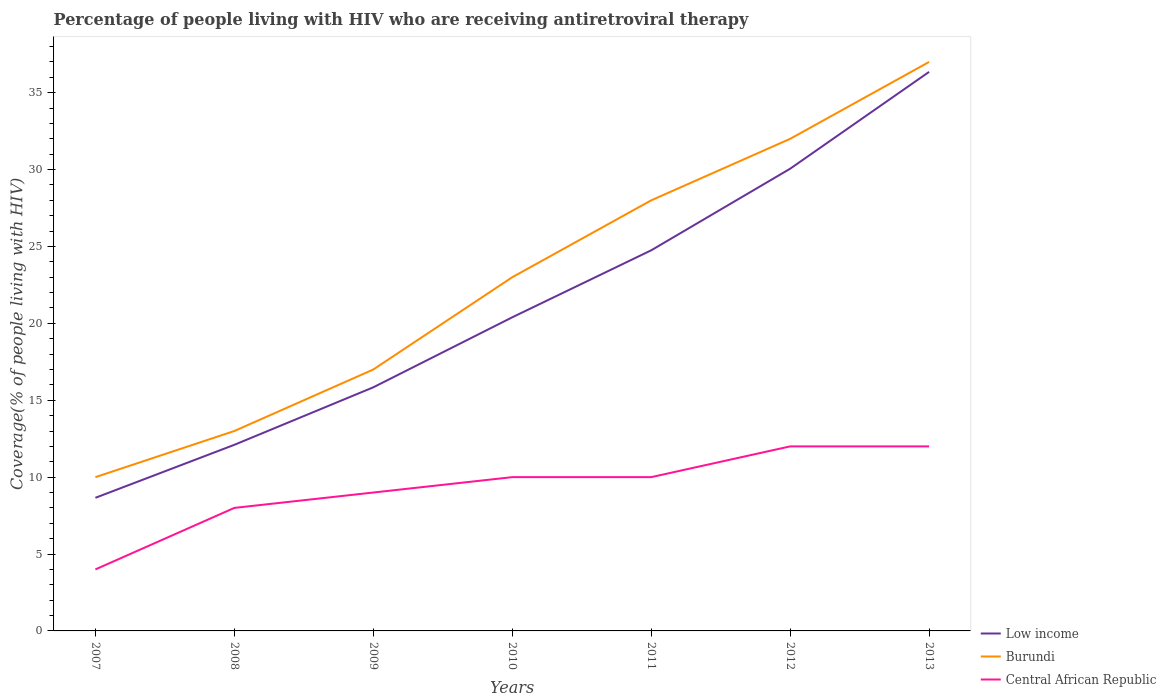How many different coloured lines are there?
Your answer should be very brief. 3. Does the line corresponding to Burundi intersect with the line corresponding to Low income?
Offer a very short reply. No. Is the number of lines equal to the number of legend labels?
Your answer should be compact. Yes. Across all years, what is the maximum percentage of the HIV infected people who are receiving antiretroviral therapy in Low income?
Make the answer very short. 8.66. In which year was the percentage of the HIV infected people who are receiving antiretroviral therapy in Burundi maximum?
Make the answer very short. 2007. What is the total percentage of the HIV infected people who are receiving antiretroviral therapy in Burundi in the graph?
Your response must be concise. -15. What is the difference between the highest and the second highest percentage of the HIV infected people who are receiving antiretroviral therapy in Low income?
Your answer should be compact. 27.7. Is the percentage of the HIV infected people who are receiving antiretroviral therapy in Central African Republic strictly greater than the percentage of the HIV infected people who are receiving antiretroviral therapy in Burundi over the years?
Offer a terse response. Yes. How many lines are there?
Make the answer very short. 3. What is the title of the graph?
Provide a short and direct response. Percentage of people living with HIV who are receiving antiretroviral therapy. Does "Sub-Saharan Africa (developing only)" appear as one of the legend labels in the graph?
Your answer should be very brief. No. What is the label or title of the X-axis?
Make the answer very short. Years. What is the label or title of the Y-axis?
Your response must be concise. Coverage(% of people living with HIV). What is the Coverage(% of people living with HIV) of Low income in 2007?
Provide a short and direct response. 8.66. What is the Coverage(% of people living with HIV) of Central African Republic in 2007?
Offer a terse response. 4. What is the Coverage(% of people living with HIV) of Low income in 2008?
Give a very brief answer. 12.1. What is the Coverage(% of people living with HIV) of Low income in 2009?
Provide a short and direct response. 15.84. What is the Coverage(% of people living with HIV) of Burundi in 2009?
Give a very brief answer. 17. What is the Coverage(% of people living with HIV) of Central African Republic in 2009?
Your answer should be very brief. 9. What is the Coverage(% of people living with HIV) in Low income in 2010?
Offer a terse response. 20.39. What is the Coverage(% of people living with HIV) of Central African Republic in 2010?
Your answer should be compact. 10. What is the Coverage(% of people living with HIV) in Low income in 2011?
Keep it short and to the point. 24.75. What is the Coverage(% of people living with HIV) in Burundi in 2011?
Ensure brevity in your answer.  28. What is the Coverage(% of people living with HIV) of Central African Republic in 2011?
Keep it short and to the point. 10. What is the Coverage(% of people living with HIV) of Low income in 2012?
Provide a short and direct response. 30.06. What is the Coverage(% of people living with HIV) of Burundi in 2012?
Your answer should be compact. 32. What is the Coverage(% of people living with HIV) in Central African Republic in 2012?
Make the answer very short. 12. What is the Coverage(% of people living with HIV) of Low income in 2013?
Your answer should be very brief. 36.35. Across all years, what is the maximum Coverage(% of people living with HIV) of Low income?
Ensure brevity in your answer.  36.35. Across all years, what is the maximum Coverage(% of people living with HIV) in Burundi?
Keep it short and to the point. 37. Across all years, what is the maximum Coverage(% of people living with HIV) in Central African Republic?
Offer a terse response. 12. Across all years, what is the minimum Coverage(% of people living with HIV) of Low income?
Offer a terse response. 8.66. Across all years, what is the minimum Coverage(% of people living with HIV) of Burundi?
Provide a short and direct response. 10. Across all years, what is the minimum Coverage(% of people living with HIV) of Central African Republic?
Provide a short and direct response. 4. What is the total Coverage(% of people living with HIV) in Low income in the graph?
Offer a very short reply. 148.16. What is the total Coverage(% of people living with HIV) of Burundi in the graph?
Your answer should be very brief. 160. What is the difference between the Coverage(% of people living with HIV) in Low income in 2007 and that in 2008?
Your answer should be compact. -3.45. What is the difference between the Coverage(% of people living with HIV) in Burundi in 2007 and that in 2008?
Make the answer very short. -3. What is the difference between the Coverage(% of people living with HIV) in Central African Republic in 2007 and that in 2008?
Your response must be concise. -4. What is the difference between the Coverage(% of people living with HIV) of Low income in 2007 and that in 2009?
Your response must be concise. -7.18. What is the difference between the Coverage(% of people living with HIV) of Burundi in 2007 and that in 2009?
Give a very brief answer. -7. What is the difference between the Coverage(% of people living with HIV) in Central African Republic in 2007 and that in 2009?
Provide a short and direct response. -5. What is the difference between the Coverage(% of people living with HIV) in Low income in 2007 and that in 2010?
Your answer should be compact. -11.74. What is the difference between the Coverage(% of people living with HIV) of Low income in 2007 and that in 2011?
Ensure brevity in your answer.  -16.09. What is the difference between the Coverage(% of people living with HIV) in Burundi in 2007 and that in 2011?
Keep it short and to the point. -18. What is the difference between the Coverage(% of people living with HIV) in Low income in 2007 and that in 2012?
Keep it short and to the point. -21.4. What is the difference between the Coverage(% of people living with HIV) of Burundi in 2007 and that in 2012?
Ensure brevity in your answer.  -22. What is the difference between the Coverage(% of people living with HIV) in Low income in 2007 and that in 2013?
Provide a short and direct response. -27.7. What is the difference between the Coverage(% of people living with HIV) of Burundi in 2007 and that in 2013?
Keep it short and to the point. -27. What is the difference between the Coverage(% of people living with HIV) of Central African Republic in 2007 and that in 2013?
Give a very brief answer. -8. What is the difference between the Coverage(% of people living with HIV) of Low income in 2008 and that in 2009?
Offer a terse response. -3.74. What is the difference between the Coverage(% of people living with HIV) in Burundi in 2008 and that in 2009?
Offer a very short reply. -4. What is the difference between the Coverage(% of people living with HIV) in Central African Republic in 2008 and that in 2009?
Provide a succinct answer. -1. What is the difference between the Coverage(% of people living with HIV) in Low income in 2008 and that in 2010?
Offer a very short reply. -8.29. What is the difference between the Coverage(% of people living with HIV) in Burundi in 2008 and that in 2010?
Give a very brief answer. -10. What is the difference between the Coverage(% of people living with HIV) in Central African Republic in 2008 and that in 2010?
Ensure brevity in your answer.  -2. What is the difference between the Coverage(% of people living with HIV) in Low income in 2008 and that in 2011?
Your answer should be compact. -12.65. What is the difference between the Coverage(% of people living with HIV) of Burundi in 2008 and that in 2011?
Give a very brief answer. -15. What is the difference between the Coverage(% of people living with HIV) in Low income in 2008 and that in 2012?
Offer a terse response. -17.95. What is the difference between the Coverage(% of people living with HIV) in Central African Republic in 2008 and that in 2012?
Provide a succinct answer. -4. What is the difference between the Coverage(% of people living with HIV) of Low income in 2008 and that in 2013?
Ensure brevity in your answer.  -24.25. What is the difference between the Coverage(% of people living with HIV) in Burundi in 2008 and that in 2013?
Ensure brevity in your answer.  -24. What is the difference between the Coverage(% of people living with HIV) of Low income in 2009 and that in 2010?
Provide a short and direct response. -4.55. What is the difference between the Coverage(% of people living with HIV) of Burundi in 2009 and that in 2010?
Provide a succinct answer. -6. What is the difference between the Coverage(% of people living with HIV) of Central African Republic in 2009 and that in 2010?
Your answer should be very brief. -1. What is the difference between the Coverage(% of people living with HIV) of Low income in 2009 and that in 2011?
Give a very brief answer. -8.91. What is the difference between the Coverage(% of people living with HIV) in Burundi in 2009 and that in 2011?
Give a very brief answer. -11. What is the difference between the Coverage(% of people living with HIV) in Low income in 2009 and that in 2012?
Give a very brief answer. -14.21. What is the difference between the Coverage(% of people living with HIV) of Burundi in 2009 and that in 2012?
Offer a terse response. -15. What is the difference between the Coverage(% of people living with HIV) in Low income in 2009 and that in 2013?
Provide a succinct answer. -20.51. What is the difference between the Coverage(% of people living with HIV) of Burundi in 2009 and that in 2013?
Your answer should be compact. -20. What is the difference between the Coverage(% of people living with HIV) in Central African Republic in 2009 and that in 2013?
Keep it short and to the point. -3. What is the difference between the Coverage(% of people living with HIV) of Low income in 2010 and that in 2011?
Ensure brevity in your answer.  -4.36. What is the difference between the Coverage(% of people living with HIV) of Burundi in 2010 and that in 2011?
Give a very brief answer. -5. What is the difference between the Coverage(% of people living with HIV) of Central African Republic in 2010 and that in 2011?
Make the answer very short. 0. What is the difference between the Coverage(% of people living with HIV) in Low income in 2010 and that in 2012?
Provide a short and direct response. -9.66. What is the difference between the Coverage(% of people living with HIV) in Central African Republic in 2010 and that in 2012?
Make the answer very short. -2. What is the difference between the Coverage(% of people living with HIV) in Low income in 2010 and that in 2013?
Make the answer very short. -15.96. What is the difference between the Coverage(% of people living with HIV) of Low income in 2011 and that in 2012?
Your response must be concise. -5.31. What is the difference between the Coverage(% of people living with HIV) of Central African Republic in 2011 and that in 2012?
Provide a short and direct response. -2. What is the difference between the Coverage(% of people living with HIV) in Low income in 2011 and that in 2013?
Keep it short and to the point. -11.6. What is the difference between the Coverage(% of people living with HIV) in Central African Republic in 2011 and that in 2013?
Make the answer very short. -2. What is the difference between the Coverage(% of people living with HIV) in Low income in 2012 and that in 2013?
Provide a succinct answer. -6.3. What is the difference between the Coverage(% of people living with HIV) of Low income in 2007 and the Coverage(% of people living with HIV) of Burundi in 2008?
Provide a short and direct response. -4.34. What is the difference between the Coverage(% of people living with HIV) in Low income in 2007 and the Coverage(% of people living with HIV) in Central African Republic in 2008?
Provide a short and direct response. 0.66. What is the difference between the Coverage(% of people living with HIV) in Burundi in 2007 and the Coverage(% of people living with HIV) in Central African Republic in 2008?
Your response must be concise. 2. What is the difference between the Coverage(% of people living with HIV) in Low income in 2007 and the Coverage(% of people living with HIV) in Burundi in 2009?
Keep it short and to the point. -8.34. What is the difference between the Coverage(% of people living with HIV) in Low income in 2007 and the Coverage(% of people living with HIV) in Central African Republic in 2009?
Make the answer very short. -0.34. What is the difference between the Coverage(% of people living with HIV) of Low income in 2007 and the Coverage(% of people living with HIV) of Burundi in 2010?
Offer a very short reply. -14.34. What is the difference between the Coverage(% of people living with HIV) in Low income in 2007 and the Coverage(% of people living with HIV) in Central African Republic in 2010?
Offer a terse response. -1.34. What is the difference between the Coverage(% of people living with HIV) of Low income in 2007 and the Coverage(% of people living with HIV) of Burundi in 2011?
Your answer should be very brief. -19.34. What is the difference between the Coverage(% of people living with HIV) in Low income in 2007 and the Coverage(% of people living with HIV) in Central African Republic in 2011?
Offer a very short reply. -1.34. What is the difference between the Coverage(% of people living with HIV) of Burundi in 2007 and the Coverage(% of people living with HIV) of Central African Republic in 2011?
Your response must be concise. 0. What is the difference between the Coverage(% of people living with HIV) of Low income in 2007 and the Coverage(% of people living with HIV) of Burundi in 2012?
Your answer should be compact. -23.34. What is the difference between the Coverage(% of people living with HIV) of Low income in 2007 and the Coverage(% of people living with HIV) of Central African Republic in 2012?
Offer a terse response. -3.34. What is the difference between the Coverage(% of people living with HIV) of Burundi in 2007 and the Coverage(% of people living with HIV) of Central African Republic in 2012?
Ensure brevity in your answer.  -2. What is the difference between the Coverage(% of people living with HIV) in Low income in 2007 and the Coverage(% of people living with HIV) in Burundi in 2013?
Provide a succinct answer. -28.34. What is the difference between the Coverage(% of people living with HIV) in Low income in 2007 and the Coverage(% of people living with HIV) in Central African Republic in 2013?
Keep it short and to the point. -3.34. What is the difference between the Coverage(% of people living with HIV) of Low income in 2008 and the Coverage(% of people living with HIV) of Burundi in 2009?
Offer a very short reply. -4.9. What is the difference between the Coverage(% of people living with HIV) of Low income in 2008 and the Coverage(% of people living with HIV) of Central African Republic in 2009?
Ensure brevity in your answer.  3.1. What is the difference between the Coverage(% of people living with HIV) of Low income in 2008 and the Coverage(% of people living with HIV) of Burundi in 2010?
Give a very brief answer. -10.9. What is the difference between the Coverage(% of people living with HIV) in Low income in 2008 and the Coverage(% of people living with HIV) in Central African Republic in 2010?
Offer a very short reply. 2.1. What is the difference between the Coverage(% of people living with HIV) in Low income in 2008 and the Coverage(% of people living with HIV) in Burundi in 2011?
Keep it short and to the point. -15.9. What is the difference between the Coverage(% of people living with HIV) in Low income in 2008 and the Coverage(% of people living with HIV) in Central African Republic in 2011?
Make the answer very short. 2.1. What is the difference between the Coverage(% of people living with HIV) of Low income in 2008 and the Coverage(% of people living with HIV) of Burundi in 2012?
Your response must be concise. -19.9. What is the difference between the Coverage(% of people living with HIV) in Low income in 2008 and the Coverage(% of people living with HIV) in Central African Republic in 2012?
Your answer should be very brief. 0.1. What is the difference between the Coverage(% of people living with HIV) in Low income in 2008 and the Coverage(% of people living with HIV) in Burundi in 2013?
Your answer should be compact. -24.9. What is the difference between the Coverage(% of people living with HIV) of Low income in 2008 and the Coverage(% of people living with HIV) of Central African Republic in 2013?
Your response must be concise. 0.1. What is the difference between the Coverage(% of people living with HIV) in Burundi in 2008 and the Coverage(% of people living with HIV) in Central African Republic in 2013?
Your response must be concise. 1. What is the difference between the Coverage(% of people living with HIV) of Low income in 2009 and the Coverage(% of people living with HIV) of Burundi in 2010?
Offer a very short reply. -7.16. What is the difference between the Coverage(% of people living with HIV) of Low income in 2009 and the Coverage(% of people living with HIV) of Central African Republic in 2010?
Your response must be concise. 5.84. What is the difference between the Coverage(% of people living with HIV) in Low income in 2009 and the Coverage(% of people living with HIV) in Burundi in 2011?
Ensure brevity in your answer.  -12.16. What is the difference between the Coverage(% of people living with HIV) in Low income in 2009 and the Coverage(% of people living with HIV) in Central African Republic in 2011?
Give a very brief answer. 5.84. What is the difference between the Coverage(% of people living with HIV) of Burundi in 2009 and the Coverage(% of people living with HIV) of Central African Republic in 2011?
Offer a very short reply. 7. What is the difference between the Coverage(% of people living with HIV) of Low income in 2009 and the Coverage(% of people living with HIV) of Burundi in 2012?
Make the answer very short. -16.16. What is the difference between the Coverage(% of people living with HIV) in Low income in 2009 and the Coverage(% of people living with HIV) in Central African Republic in 2012?
Offer a very short reply. 3.84. What is the difference between the Coverage(% of people living with HIV) of Low income in 2009 and the Coverage(% of people living with HIV) of Burundi in 2013?
Give a very brief answer. -21.16. What is the difference between the Coverage(% of people living with HIV) of Low income in 2009 and the Coverage(% of people living with HIV) of Central African Republic in 2013?
Your response must be concise. 3.84. What is the difference between the Coverage(% of people living with HIV) in Burundi in 2009 and the Coverage(% of people living with HIV) in Central African Republic in 2013?
Your response must be concise. 5. What is the difference between the Coverage(% of people living with HIV) of Low income in 2010 and the Coverage(% of people living with HIV) of Burundi in 2011?
Your answer should be compact. -7.61. What is the difference between the Coverage(% of people living with HIV) in Low income in 2010 and the Coverage(% of people living with HIV) in Central African Republic in 2011?
Provide a succinct answer. 10.39. What is the difference between the Coverage(% of people living with HIV) of Burundi in 2010 and the Coverage(% of people living with HIV) of Central African Republic in 2011?
Make the answer very short. 13. What is the difference between the Coverage(% of people living with HIV) in Low income in 2010 and the Coverage(% of people living with HIV) in Burundi in 2012?
Your answer should be compact. -11.61. What is the difference between the Coverage(% of people living with HIV) in Low income in 2010 and the Coverage(% of people living with HIV) in Central African Republic in 2012?
Your response must be concise. 8.39. What is the difference between the Coverage(% of people living with HIV) in Burundi in 2010 and the Coverage(% of people living with HIV) in Central African Republic in 2012?
Provide a short and direct response. 11. What is the difference between the Coverage(% of people living with HIV) in Low income in 2010 and the Coverage(% of people living with HIV) in Burundi in 2013?
Give a very brief answer. -16.61. What is the difference between the Coverage(% of people living with HIV) of Low income in 2010 and the Coverage(% of people living with HIV) of Central African Republic in 2013?
Your answer should be very brief. 8.39. What is the difference between the Coverage(% of people living with HIV) in Burundi in 2010 and the Coverage(% of people living with HIV) in Central African Republic in 2013?
Offer a very short reply. 11. What is the difference between the Coverage(% of people living with HIV) in Low income in 2011 and the Coverage(% of people living with HIV) in Burundi in 2012?
Your answer should be compact. -7.25. What is the difference between the Coverage(% of people living with HIV) in Low income in 2011 and the Coverage(% of people living with HIV) in Central African Republic in 2012?
Ensure brevity in your answer.  12.75. What is the difference between the Coverage(% of people living with HIV) in Burundi in 2011 and the Coverage(% of people living with HIV) in Central African Republic in 2012?
Ensure brevity in your answer.  16. What is the difference between the Coverage(% of people living with HIV) in Low income in 2011 and the Coverage(% of people living with HIV) in Burundi in 2013?
Offer a terse response. -12.25. What is the difference between the Coverage(% of people living with HIV) of Low income in 2011 and the Coverage(% of people living with HIV) of Central African Republic in 2013?
Your answer should be very brief. 12.75. What is the difference between the Coverage(% of people living with HIV) of Burundi in 2011 and the Coverage(% of people living with HIV) of Central African Republic in 2013?
Give a very brief answer. 16. What is the difference between the Coverage(% of people living with HIV) in Low income in 2012 and the Coverage(% of people living with HIV) in Burundi in 2013?
Offer a very short reply. -6.94. What is the difference between the Coverage(% of people living with HIV) in Low income in 2012 and the Coverage(% of people living with HIV) in Central African Republic in 2013?
Your response must be concise. 18.06. What is the difference between the Coverage(% of people living with HIV) in Burundi in 2012 and the Coverage(% of people living with HIV) in Central African Republic in 2013?
Your response must be concise. 20. What is the average Coverage(% of people living with HIV) in Low income per year?
Keep it short and to the point. 21.17. What is the average Coverage(% of people living with HIV) in Burundi per year?
Make the answer very short. 22.86. What is the average Coverage(% of people living with HIV) in Central African Republic per year?
Your answer should be very brief. 9.29. In the year 2007, what is the difference between the Coverage(% of people living with HIV) in Low income and Coverage(% of people living with HIV) in Burundi?
Your answer should be compact. -1.34. In the year 2007, what is the difference between the Coverage(% of people living with HIV) of Low income and Coverage(% of people living with HIV) of Central African Republic?
Provide a short and direct response. 4.66. In the year 2007, what is the difference between the Coverage(% of people living with HIV) of Burundi and Coverage(% of people living with HIV) of Central African Republic?
Ensure brevity in your answer.  6. In the year 2008, what is the difference between the Coverage(% of people living with HIV) in Low income and Coverage(% of people living with HIV) in Burundi?
Make the answer very short. -0.9. In the year 2008, what is the difference between the Coverage(% of people living with HIV) in Low income and Coverage(% of people living with HIV) in Central African Republic?
Your response must be concise. 4.1. In the year 2009, what is the difference between the Coverage(% of people living with HIV) in Low income and Coverage(% of people living with HIV) in Burundi?
Provide a succinct answer. -1.16. In the year 2009, what is the difference between the Coverage(% of people living with HIV) of Low income and Coverage(% of people living with HIV) of Central African Republic?
Make the answer very short. 6.84. In the year 2010, what is the difference between the Coverage(% of people living with HIV) of Low income and Coverage(% of people living with HIV) of Burundi?
Provide a short and direct response. -2.61. In the year 2010, what is the difference between the Coverage(% of people living with HIV) in Low income and Coverage(% of people living with HIV) in Central African Republic?
Make the answer very short. 10.39. In the year 2011, what is the difference between the Coverage(% of people living with HIV) in Low income and Coverage(% of people living with HIV) in Burundi?
Offer a very short reply. -3.25. In the year 2011, what is the difference between the Coverage(% of people living with HIV) in Low income and Coverage(% of people living with HIV) in Central African Republic?
Make the answer very short. 14.75. In the year 2012, what is the difference between the Coverage(% of people living with HIV) in Low income and Coverage(% of people living with HIV) in Burundi?
Provide a short and direct response. -1.94. In the year 2012, what is the difference between the Coverage(% of people living with HIV) in Low income and Coverage(% of people living with HIV) in Central African Republic?
Give a very brief answer. 18.06. In the year 2012, what is the difference between the Coverage(% of people living with HIV) of Burundi and Coverage(% of people living with HIV) of Central African Republic?
Keep it short and to the point. 20. In the year 2013, what is the difference between the Coverage(% of people living with HIV) in Low income and Coverage(% of people living with HIV) in Burundi?
Make the answer very short. -0.65. In the year 2013, what is the difference between the Coverage(% of people living with HIV) of Low income and Coverage(% of people living with HIV) of Central African Republic?
Offer a very short reply. 24.35. What is the ratio of the Coverage(% of people living with HIV) in Low income in 2007 to that in 2008?
Make the answer very short. 0.72. What is the ratio of the Coverage(% of people living with HIV) of Burundi in 2007 to that in 2008?
Ensure brevity in your answer.  0.77. What is the ratio of the Coverage(% of people living with HIV) of Central African Republic in 2007 to that in 2008?
Provide a short and direct response. 0.5. What is the ratio of the Coverage(% of people living with HIV) of Low income in 2007 to that in 2009?
Your response must be concise. 0.55. What is the ratio of the Coverage(% of people living with HIV) in Burundi in 2007 to that in 2009?
Offer a terse response. 0.59. What is the ratio of the Coverage(% of people living with HIV) of Central African Republic in 2007 to that in 2009?
Your response must be concise. 0.44. What is the ratio of the Coverage(% of people living with HIV) in Low income in 2007 to that in 2010?
Ensure brevity in your answer.  0.42. What is the ratio of the Coverage(% of people living with HIV) in Burundi in 2007 to that in 2010?
Your response must be concise. 0.43. What is the ratio of the Coverage(% of people living with HIV) of Central African Republic in 2007 to that in 2010?
Offer a very short reply. 0.4. What is the ratio of the Coverage(% of people living with HIV) in Low income in 2007 to that in 2011?
Provide a short and direct response. 0.35. What is the ratio of the Coverage(% of people living with HIV) of Burundi in 2007 to that in 2011?
Your answer should be compact. 0.36. What is the ratio of the Coverage(% of people living with HIV) of Low income in 2007 to that in 2012?
Give a very brief answer. 0.29. What is the ratio of the Coverage(% of people living with HIV) in Burundi in 2007 to that in 2012?
Offer a very short reply. 0.31. What is the ratio of the Coverage(% of people living with HIV) in Central African Republic in 2007 to that in 2012?
Provide a succinct answer. 0.33. What is the ratio of the Coverage(% of people living with HIV) of Low income in 2007 to that in 2013?
Give a very brief answer. 0.24. What is the ratio of the Coverage(% of people living with HIV) in Burundi in 2007 to that in 2013?
Make the answer very short. 0.27. What is the ratio of the Coverage(% of people living with HIV) of Low income in 2008 to that in 2009?
Your answer should be compact. 0.76. What is the ratio of the Coverage(% of people living with HIV) of Burundi in 2008 to that in 2009?
Keep it short and to the point. 0.76. What is the ratio of the Coverage(% of people living with HIV) in Central African Republic in 2008 to that in 2009?
Offer a terse response. 0.89. What is the ratio of the Coverage(% of people living with HIV) in Low income in 2008 to that in 2010?
Your answer should be very brief. 0.59. What is the ratio of the Coverage(% of people living with HIV) in Burundi in 2008 to that in 2010?
Provide a short and direct response. 0.57. What is the ratio of the Coverage(% of people living with HIV) of Low income in 2008 to that in 2011?
Your answer should be very brief. 0.49. What is the ratio of the Coverage(% of people living with HIV) in Burundi in 2008 to that in 2011?
Provide a succinct answer. 0.46. What is the ratio of the Coverage(% of people living with HIV) in Central African Republic in 2008 to that in 2011?
Offer a very short reply. 0.8. What is the ratio of the Coverage(% of people living with HIV) in Low income in 2008 to that in 2012?
Your response must be concise. 0.4. What is the ratio of the Coverage(% of people living with HIV) of Burundi in 2008 to that in 2012?
Keep it short and to the point. 0.41. What is the ratio of the Coverage(% of people living with HIV) of Low income in 2008 to that in 2013?
Give a very brief answer. 0.33. What is the ratio of the Coverage(% of people living with HIV) of Burundi in 2008 to that in 2013?
Make the answer very short. 0.35. What is the ratio of the Coverage(% of people living with HIV) in Low income in 2009 to that in 2010?
Give a very brief answer. 0.78. What is the ratio of the Coverage(% of people living with HIV) in Burundi in 2009 to that in 2010?
Your answer should be very brief. 0.74. What is the ratio of the Coverage(% of people living with HIV) of Central African Republic in 2009 to that in 2010?
Give a very brief answer. 0.9. What is the ratio of the Coverage(% of people living with HIV) in Low income in 2009 to that in 2011?
Your answer should be compact. 0.64. What is the ratio of the Coverage(% of people living with HIV) in Burundi in 2009 to that in 2011?
Your answer should be compact. 0.61. What is the ratio of the Coverage(% of people living with HIV) in Low income in 2009 to that in 2012?
Provide a short and direct response. 0.53. What is the ratio of the Coverage(% of people living with HIV) in Burundi in 2009 to that in 2012?
Ensure brevity in your answer.  0.53. What is the ratio of the Coverage(% of people living with HIV) of Low income in 2009 to that in 2013?
Ensure brevity in your answer.  0.44. What is the ratio of the Coverage(% of people living with HIV) of Burundi in 2009 to that in 2013?
Your answer should be compact. 0.46. What is the ratio of the Coverage(% of people living with HIV) in Central African Republic in 2009 to that in 2013?
Give a very brief answer. 0.75. What is the ratio of the Coverage(% of people living with HIV) in Low income in 2010 to that in 2011?
Keep it short and to the point. 0.82. What is the ratio of the Coverage(% of people living with HIV) of Burundi in 2010 to that in 2011?
Give a very brief answer. 0.82. What is the ratio of the Coverage(% of people living with HIV) of Central African Republic in 2010 to that in 2011?
Your answer should be very brief. 1. What is the ratio of the Coverage(% of people living with HIV) in Low income in 2010 to that in 2012?
Offer a very short reply. 0.68. What is the ratio of the Coverage(% of people living with HIV) of Burundi in 2010 to that in 2012?
Offer a very short reply. 0.72. What is the ratio of the Coverage(% of people living with HIV) in Central African Republic in 2010 to that in 2012?
Your answer should be compact. 0.83. What is the ratio of the Coverage(% of people living with HIV) of Low income in 2010 to that in 2013?
Provide a succinct answer. 0.56. What is the ratio of the Coverage(% of people living with HIV) in Burundi in 2010 to that in 2013?
Ensure brevity in your answer.  0.62. What is the ratio of the Coverage(% of people living with HIV) of Low income in 2011 to that in 2012?
Give a very brief answer. 0.82. What is the ratio of the Coverage(% of people living with HIV) in Low income in 2011 to that in 2013?
Your response must be concise. 0.68. What is the ratio of the Coverage(% of people living with HIV) of Burundi in 2011 to that in 2013?
Keep it short and to the point. 0.76. What is the ratio of the Coverage(% of people living with HIV) in Low income in 2012 to that in 2013?
Make the answer very short. 0.83. What is the ratio of the Coverage(% of people living with HIV) in Burundi in 2012 to that in 2013?
Offer a terse response. 0.86. What is the difference between the highest and the second highest Coverage(% of people living with HIV) in Low income?
Your answer should be very brief. 6.3. What is the difference between the highest and the second highest Coverage(% of people living with HIV) in Burundi?
Your answer should be very brief. 5. What is the difference between the highest and the second highest Coverage(% of people living with HIV) in Central African Republic?
Your answer should be compact. 0. What is the difference between the highest and the lowest Coverage(% of people living with HIV) in Low income?
Offer a very short reply. 27.7. What is the difference between the highest and the lowest Coverage(% of people living with HIV) in Central African Republic?
Your response must be concise. 8. 